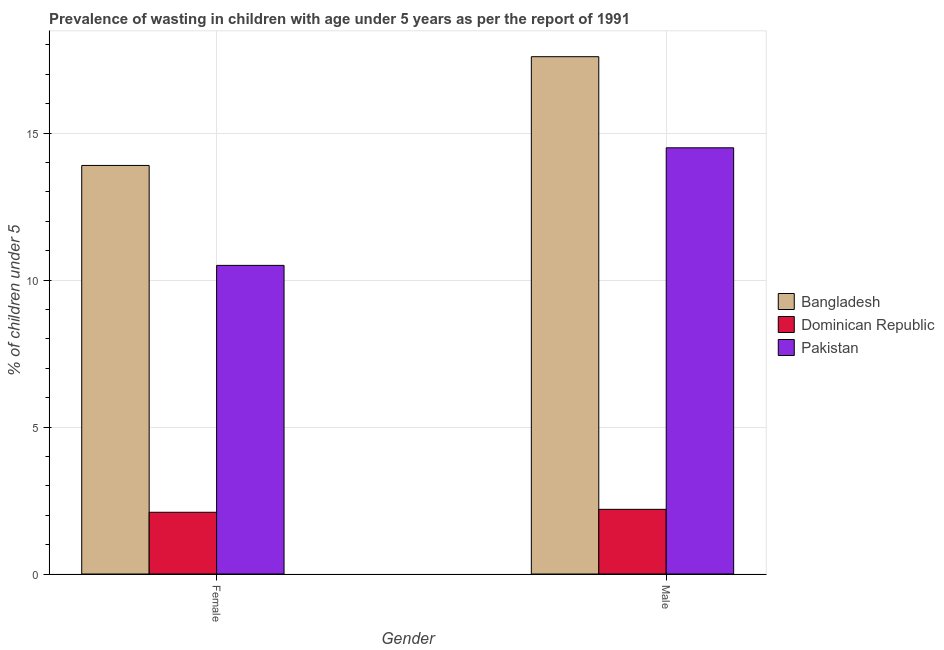How many different coloured bars are there?
Make the answer very short. 3. How many groups of bars are there?
Offer a very short reply. 2. Are the number of bars on each tick of the X-axis equal?
Your answer should be compact. Yes. How many bars are there on the 1st tick from the left?
Offer a very short reply. 3. What is the label of the 2nd group of bars from the left?
Give a very brief answer. Male. What is the percentage of undernourished male children in Pakistan?
Your answer should be compact. 14.5. Across all countries, what is the maximum percentage of undernourished male children?
Keep it short and to the point. 17.6. Across all countries, what is the minimum percentage of undernourished male children?
Offer a very short reply. 2.2. In which country was the percentage of undernourished male children maximum?
Your answer should be compact. Bangladesh. In which country was the percentage of undernourished female children minimum?
Offer a terse response. Dominican Republic. What is the total percentage of undernourished female children in the graph?
Provide a succinct answer. 26.5. What is the difference between the percentage of undernourished male children in Bangladesh and that in Pakistan?
Provide a succinct answer. 3.1. What is the difference between the percentage of undernourished male children in Dominican Republic and the percentage of undernourished female children in Bangladesh?
Your answer should be compact. -11.7. What is the average percentage of undernourished female children per country?
Provide a short and direct response. 8.83. What is the difference between the percentage of undernourished female children and percentage of undernourished male children in Dominican Republic?
Give a very brief answer. -0.1. What is the ratio of the percentage of undernourished female children in Pakistan to that in Bangladesh?
Your response must be concise. 0.76. Is the percentage of undernourished female children in Bangladesh less than that in Pakistan?
Offer a very short reply. No. In how many countries, is the percentage of undernourished male children greater than the average percentage of undernourished male children taken over all countries?
Your answer should be very brief. 2. What does the 3rd bar from the left in Male represents?
Provide a short and direct response. Pakistan. How many countries are there in the graph?
Ensure brevity in your answer.  3. Does the graph contain grids?
Provide a succinct answer. Yes. What is the title of the graph?
Keep it short and to the point. Prevalence of wasting in children with age under 5 years as per the report of 1991. Does "Sub-Saharan Africa (developing only)" appear as one of the legend labels in the graph?
Make the answer very short. No. What is the label or title of the X-axis?
Provide a short and direct response. Gender. What is the label or title of the Y-axis?
Provide a short and direct response.  % of children under 5. What is the  % of children under 5 in Bangladesh in Female?
Make the answer very short. 13.9. What is the  % of children under 5 of Dominican Republic in Female?
Give a very brief answer. 2.1. What is the  % of children under 5 in Pakistan in Female?
Your answer should be very brief. 10.5. What is the  % of children under 5 of Bangladesh in Male?
Offer a terse response. 17.6. What is the  % of children under 5 of Dominican Republic in Male?
Provide a short and direct response. 2.2. Across all Gender, what is the maximum  % of children under 5 of Bangladesh?
Provide a short and direct response. 17.6. Across all Gender, what is the maximum  % of children under 5 in Dominican Republic?
Offer a terse response. 2.2. Across all Gender, what is the minimum  % of children under 5 in Bangladesh?
Provide a succinct answer. 13.9. Across all Gender, what is the minimum  % of children under 5 of Dominican Republic?
Provide a short and direct response. 2.1. Across all Gender, what is the minimum  % of children under 5 of Pakistan?
Give a very brief answer. 10.5. What is the total  % of children under 5 in Bangladesh in the graph?
Your response must be concise. 31.5. What is the difference between the  % of children under 5 of Bangladesh in Female and the  % of children under 5 of Dominican Republic in Male?
Make the answer very short. 11.7. What is the difference between the  % of children under 5 in Bangladesh in Female and the  % of children under 5 in Pakistan in Male?
Keep it short and to the point. -0.6. What is the average  % of children under 5 of Bangladesh per Gender?
Offer a very short reply. 15.75. What is the average  % of children under 5 in Dominican Republic per Gender?
Provide a succinct answer. 2.15. What is the difference between the  % of children under 5 in Bangladesh and  % of children under 5 in Pakistan in Female?
Your response must be concise. 3.4. What is the difference between the  % of children under 5 in Dominican Republic and  % of children under 5 in Pakistan in Female?
Provide a succinct answer. -8.4. What is the difference between the  % of children under 5 of Bangladesh and  % of children under 5 of Dominican Republic in Male?
Ensure brevity in your answer.  15.4. What is the difference between the  % of children under 5 in Bangladesh and  % of children under 5 in Pakistan in Male?
Your response must be concise. 3.1. What is the ratio of the  % of children under 5 of Bangladesh in Female to that in Male?
Offer a very short reply. 0.79. What is the ratio of the  % of children under 5 in Dominican Republic in Female to that in Male?
Offer a very short reply. 0.95. What is the ratio of the  % of children under 5 of Pakistan in Female to that in Male?
Give a very brief answer. 0.72. What is the difference between the highest and the second highest  % of children under 5 of Bangladesh?
Provide a succinct answer. 3.7. What is the difference between the highest and the second highest  % of children under 5 of Dominican Republic?
Your response must be concise. 0.1. What is the difference between the highest and the second highest  % of children under 5 of Pakistan?
Offer a very short reply. 4. What is the difference between the highest and the lowest  % of children under 5 in Bangladesh?
Your response must be concise. 3.7. What is the difference between the highest and the lowest  % of children under 5 in Pakistan?
Provide a succinct answer. 4. 